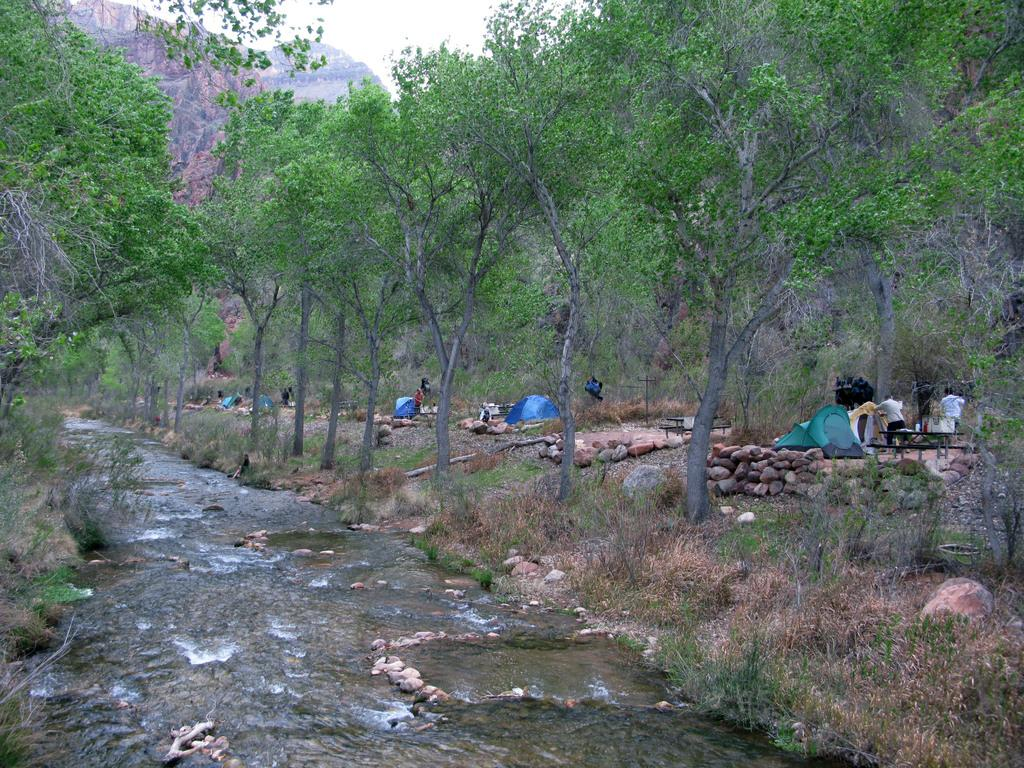What type of natural feature is present in the image? There is a river in the image. What other natural elements can be seen in the image? There are trees, plants, and a hill visible in the image. Where are the people and tents located in the image? The people and tents are on the right side of the image. What else can be found on the right side of the image? There are rocks on the right side of the image. What is visible in the background of the image? The sky is visible in the background of the image. What type of spoon is being used by the people in the image? There is no spoon visible in the image. Is there a cave in the image? No, there is no cave present in the image. 